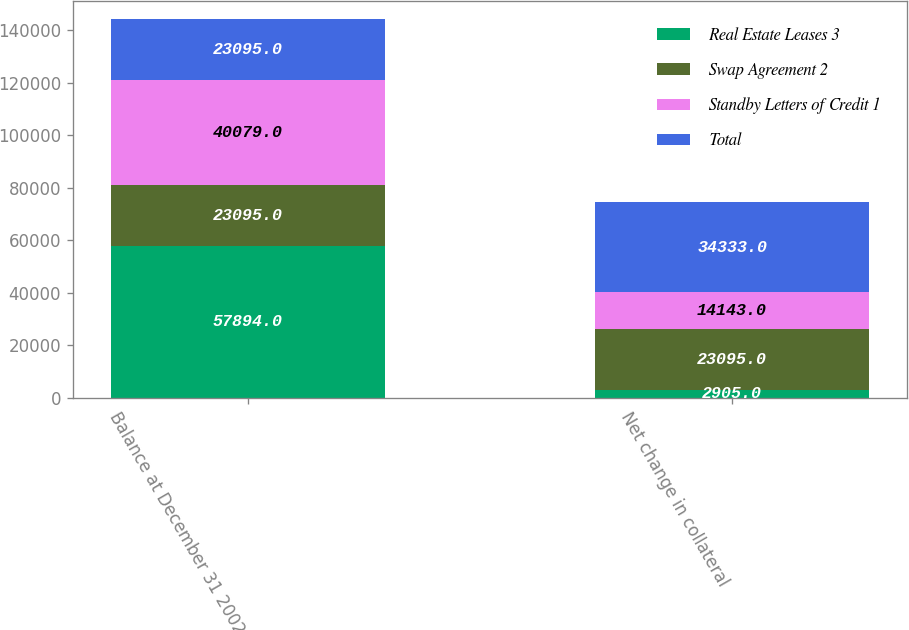Convert chart to OTSL. <chart><loc_0><loc_0><loc_500><loc_500><stacked_bar_chart><ecel><fcel>Balance at December 31 2002<fcel>Net change in collateral<nl><fcel>Real Estate Leases 3<fcel>57894<fcel>2905<nl><fcel>Swap Agreement 2<fcel>23095<fcel>23095<nl><fcel>Standby Letters of Credit 1<fcel>40079<fcel>14143<nl><fcel>Total<fcel>23095<fcel>34333<nl></chart> 